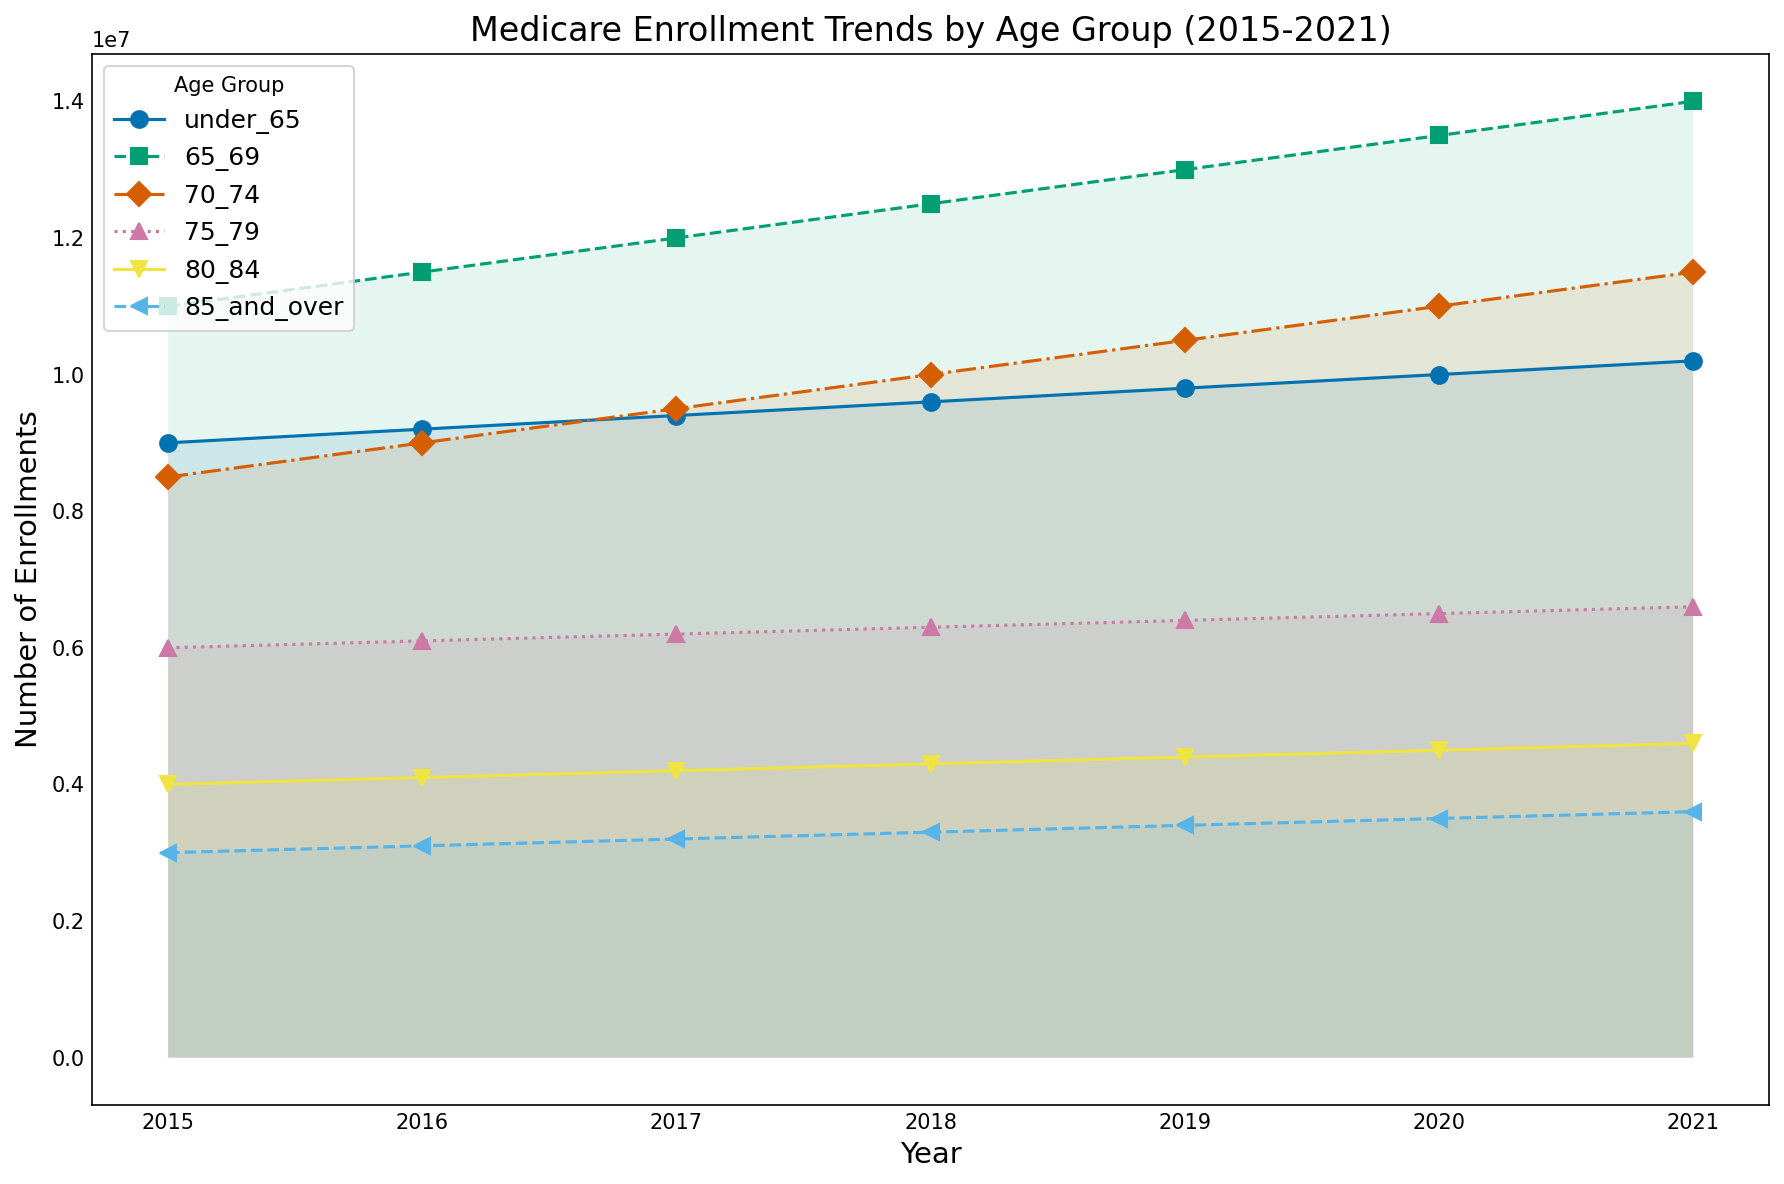What age group saw the most significant increase in enrollments from 2015 to 2021? To determine the age group with the most significant increase, we need to calculate the difference between the enrollments in 2021 and 2015 for each age group. The differences are: "under 65" (10200000 - 9000000 = 1200000), "65-69" (14000000 - 11000000 = 3000000), "70-74" (11500000 - 8500000 = 3000000), "75-79" (6600000 - 6000000 = 600000), "80-84" (4600000 - 4000000 = 600000), "85 and over" (3600000 - 3000000 = 600000). The age groups 65-69 and 70-74 both saw an increase of 3000000.
Answer: 65-69 and 70-74 Between 2015 and 2021, which age group consistently had the lowest number of enrollments? By observing the graph's lines and filling between them, it becomes apparent that the "85 and over" age group consistently maintained the lowest number of enrollments across all years from 2015 to 2021.
Answer: 85 and over How did the number of enrollments in the "under 65" age group change from 2015 to 2021? We can observe the starting and ending points of the "under 65" line. In 2015, it starts at 9000000 and increases to 10200000 by 2021. The number of enrollments increased by (10200000 - 9000000) = 1200000.
Answer: Increased by 1200000 For which year did the "75-79" age group see the smallest increase in enrollments? We should compare the year-to-year increments for the "75-79" age group to determine the smallest increase. The year-to-year increases are: 2015-2016 (100000), 2016-2017 (100000), 2017-2018 (100000), 2018-2019 (100000), 2019-2020 (100000), 2020-2021 (100000). Every year saw identical increases of 100000 enrollments. Thus, all increments are equal.
Answer: Every year Which two age groups had the closest number of enrollments in 2021? We compare the 2021 values for all age groups: "under 65" (10200000), "65-69" (14000000), "70-74" (11500000), "75-79" (6600000), "80-84" (4600000), "85 and over" (3600000). The closest enrollments are between "under 65" (10200000) and "70-74" (11500000), with a difference of 1300000.
Answer: under 65 and 70-74 Are there any age groups where enrollment numbers decreased over the years? By observing the trends of the lines from 2015 to 2021, it is clear that all age groups show an upward trend with no decreases. Each line's endpoint in 2021 is higher than its starting point in 2015.
Answer: No Which age group started with the highest number of enrollments in 2015, and how much did it change by 2021? The age group "65-69" started the highest in 2015 with 11000000 enrollments. By 2021, it increased to 14000000. The change in enrollments is (14000000 - 11000000) = 3000000.
Answer: 65-69, increased by 3000000 